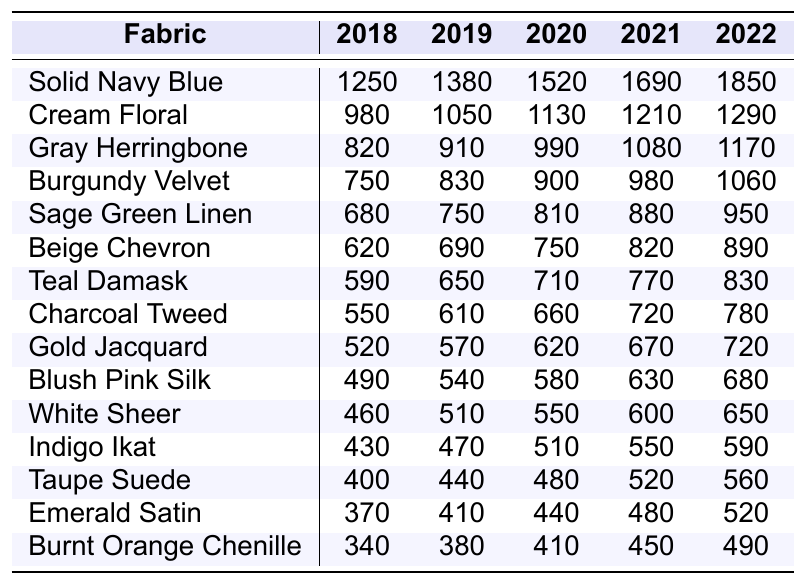What is the total sales of Solid Navy Blue fabric over the past five years? To find the total sales, add the yearly sales figures: 1250 + 1380 + 1520 + 1690 + 1850 = 6690.
Answer: 6690 Which fabric had the highest sales in 2022? In 2022, Solid Navy Blue had 1850 sales, which is higher than any other fabric listed in that year.
Answer: Solid Navy Blue What is the sales difference for Burgundy Velvet between 2018 and 2022? Calculate the difference by subtracting the 2018 sales (750) from the 2022 sales (1060): 1060 - 750 = 310.
Answer: 310 What color fabric had the lowest sales in 2020? In 2020, Burnt Orange Chenille had the lowest sales with 410, lower than all other fabrics for that year.
Answer: Burnt Orange Chenille What is the average yearly sales for Teal Damask over the five years? Calculate the average by summing the sales figures for each year (590 + 650 + 710 + 770 + 830 = 3550) and dividing by 5, resulting in 3550 / 5 = 710.
Answer: 710 Did the sales of Gray Herringbone increase every year from 2018 to 2022? On checking the values, Gray Herringbone sales increased each year: 820, 910, 990, 1080, and 1170, confirming a consistent increase.
Answer: Yes How many fabrics had sales over 1000 in 2021? Review the sales for 2021: Solid Navy Blue (1690), Cream Floral (1210), Gray Herringbone (1080), and Burgundy Velvet (980) had at least 1000 sales. Thus, 3 fabrics met the criteria.
Answer: 3 Which fabric has the highest average sales over the five years? Calculate the averages: Solid Navy Blue (1338), Cream Floral (1110), Burgundy Velvet (934), etc. Solid Navy Blue has the highest average sales.
Answer: Solid Navy Blue What percentage increase in sales did Sage Green Linen experience from 2018 to 2022? Sales in 2018=680 and in 2022=950. The percentage increase is ((950 - 680) / 680) * 100 = 39.71%.
Answer: 39.71% Is there a year where sales of Blush Pink Silk were below 500? The sales values of Blush Pink Silk in each year from 2018 to 2022 are 490, 540, 580, 630, and 680. The first year (2018) fell below 500.
Answer: Yes 